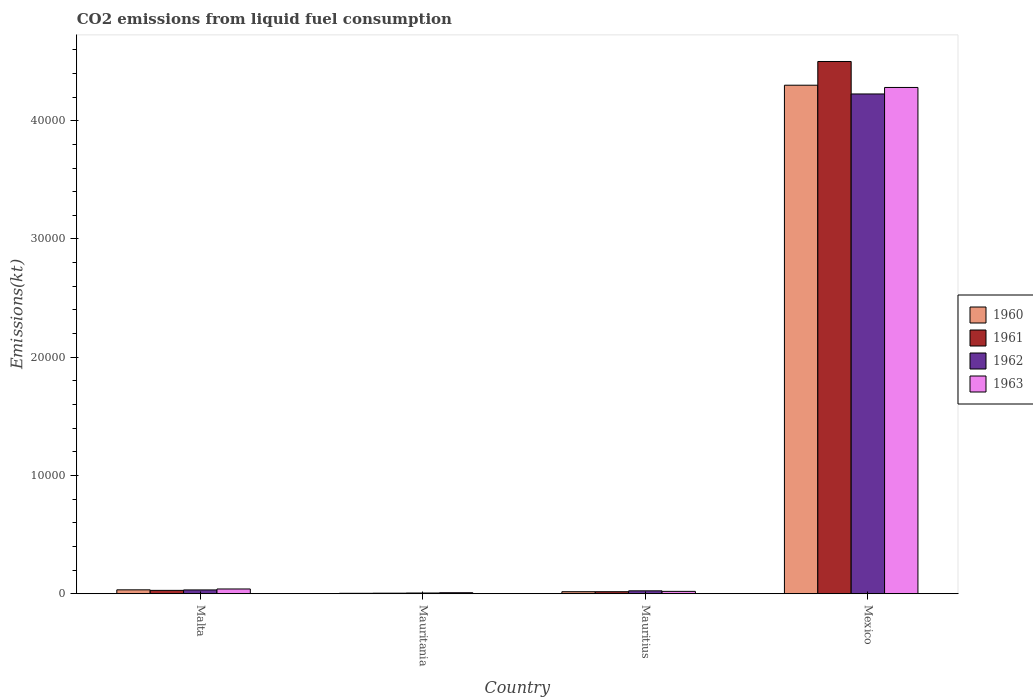How many different coloured bars are there?
Ensure brevity in your answer.  4. How many groups of bars are there?
Your answer should be compact. 4. Are the number of bars per tick equal to the number of legend labels?
Provide a short and direct response. Yes. How many bars are there on the 4th tick from the right?
Offer a very short reply. 4. What is the label of the 2nd group of bars from the left?
Provide a short and direct response. Mauritania. What is the amount of CO2 emitted in 1960 in Malta?
Provide a short and direct response. 330.03. Across all countries, what is the maximum amount of CO2 emitted in 1961?
Ensure brevity in your answer.  4.50e+04. Across all countries, what is the minimum amount of CO2 emitted in 1963?
Ensure brevity in your answer.  88.01. In which country was the amount of CO2 emitted in 1961 minimum?
Your answer should be very brief. Mauritania. What is the total amount of CO2 emitted in 1960 in the graph?
Your answer should be very brief. 4.35e+04. What is the difference between the amount of CO2 emitted in 1962 in Malta and that in Mauritania?
Make the answer very short. 260.36. What is the difference between the amount of CO2 emitted in 1962 in Mexico and the amount of CO2 emitted in 1963 in Mauritius?
Give a very brief answer. 4.21e+04. What is the average amount of CO2 emitted in 1961 per country?
Provide a short and direct response. 1.14e+04. What is the difference between the amount of CO2 emitted of/in 1960 and amount of CO2 emitted of/in 1961 in Mauritania?
Provide a succinct answer. -11. In how many countries, is the amount of CO2 emitted in 1963 greater than 36000 kt?
Ensure brevity in your answer.  1. What is the ratio of the amount of CO2 emitted in 1963 in Malta to that in Mexico?
Your response must be concise. 0.01. Is the amount of CO2 emitted in 1960 in Malta less than that in Mauritania?
Give a very brief answer. No. What is the difference between the highest and the second highest amount of CO2 emitted in 1962?
Your response must be concise. 77.01. What is the difference between the highest and the lowest amount of CO2 emitted in 1962?
Offer a very short reply. 4.22e+04. Is the sum of the amount of CO2 emitted in 1962 in Malta and Mauritius greater than the maximum amount of CO2 emitted in 1960 across all countries?
Make the answer very short. No. Is it the case that in every country, the sum of the amount of CO2 emitted in 1963 and amount of CO2 emitted in 1961 is greater than the sum of amount of CO2 emitted in 1960 and amount of CO2 emitted in 1962?
Provide a short and direct response. No. What does the 2nd bar from the left in Malta represents?
Provide a succinct answer. 1961. How many bars are there?
Make the answer very short. 16. How many countries are there in the graph?
Provide a succinct answer. 4. Does the graph contain any zero values?
Provide a succinct answer. No. Does the graph contain grids?
Give a very brief answer. No. What is the title of the graph?
Your response must be concise. CO2 emissions from liquid fuel consumption. What is the label or title of the X-axis?
Give a very brief answer. Country. What is the label or title of the Y-axis?
Give a very brief answer. Emissions(kt). What is the Emissions(kt) of 1960 in Malta?
Ensure brevity in your answer.  330.03. What is the Emissions(kt) in 1961 in Malta?
Offer a very short reply. 286.03. What is the Emissions(kt) of 1962 in Malta?
Your answer should be very brief. 322.7. What is the Emissions(kt) in 1963 in Malta?
Offer a very short reply. 403.37. What is the Emissions(kt) of 1960 in Mauritania?
Your answer should be very brief. 36.67. What is the Emissions(kt) in 1961 in Mauritania?
Your response must be concise. 47.67. What is the Emissions(kt) in 1962 in Mauritania?
Your answer should be very brief. 62.34. What is the Emissions(kt) in 1963 in Mauritania?
Give a very brief answer. 88.01. What is the Emissions(kt) of 1960 in Mauritius?
Offer a terse response. 172.35. What is the Emissions(kt) in 1961 in Mauritius?
Give a very brief answer. 172.35. What is the Emissions(kt) in 1962 in Mauritius?
Your answer should be compact. 245.69. What is the Emissions(kt) in 1963 in Mauritius?
Make the answer very short. 201.69. What is the Emissions(kt) in 1960 in Mexico?
Provide a short and direct response. 4.30e+04. What is the Emissions(kt) of 1961 in Mexico?
Offer a terse response. 4.50e+04. What is the Emissions(kt) of 1962 in Mexico?
Offer a very short reply. 4.23e+04. What is the Emissions(kt) in 1963 in Mexico?
Provide a succinct answer. 4.28e+04. Across all countries, what is the maximum Emissions(kt) in 1960?
Your answer should be compact. 4.30e+04. Across all countries, what is the maximum Emissions(kt) in 1961?
Your response must be concise. 4.50e+04. Across all countries, what is the maximum Emissions(kt) in 1962?
Provide a succinct answer. 4.23e+04. Across all countries, what is the maximum Emissions(kt) of 1963?
Your answer should be compact. 4.28e+04. Across all countries, what is the minimum Emissions(kt) in 1960?
Make the answer very short. 36.67. Across all countries, what is the minimum Emissions(kt) in 1961?
Keep it short and to the point. 47.67. Across all countries, what is the minimum Emissions(kt) of 1962?
Make the answer very short. 62.34. Across all countries, what is the minimum Emissions(kt) of 1963?
Your answer should be compact. 88.01. What is the total Emissions(kt) in 1960 in the graph?
Provide a succinct answer. 4.35e+04. What is the total Emissions(kt) in 1961 in the graph?
Offer a terse response. 4.55e+04. What is the total Emissions(kt) in 1962 in the graph?
Keep it short and to the point. 4.29e+04. What is the total Emissions(kt) of 1963 in the graph?
Your answer should be very brief. 4.35e+04. What is the difference between the Emissions(kt) of 1960 in Malta and that in Mauritania?
Provide a succinct answer. 293.36. What is the difference between the Emissions(kt) in 1961 in Malta and that in Mauritania?
Offer a terse response. 238.35. What is the difference between the Emissions(kt) of 1962 in Malta and that in Mauritania?
Your response must be concise. 260.36. What is the difference between the Emissions(kt) in 1963 in Malta and that in Mauritania?
Your answer should be compact. 315.36. What is the difference between the Emissions(kt) in 1960 in Malta and that in Mauritius?
Provide a short and direct response. 157.68. What is the difference between the Emissions(kt) in 1961 in Malta and that in Mauritius?
Your answer should be compact. 113.68. What is the difference between the Emissions(kt) of 1962 in Malta and that in Mauritius?
Provide a short and direct response. 77.01. What is the difference between the Emissions(kt) in 1963 in Malta and that in Mauritius?
Give a very brief answer. 201.69. What is the difference between the Emissions(kt) in 1960 in Malta and that in Mexico?
Make the answer very short. -4.27e+04. What is the difference between the Emissions(kt) in 1961 in Malta and that in Mexico?
Give a very brief answer. -4.47e+04. What is the difference between the Emissions(kt) of 1962 in Malta and that in Mexico?
Offer a terse response. -4.19e+04. What is the difference between the Emissions(kt) in 1963 in Malta and that in Mexico?
Offer a very short reply. -4.24e+04. What is the difference between the Emissions(kt) in 1960 in Mauritania and that in Mauritius?
Your answer should be very brief. -135.68. What is the difference between the Emissions(kt) in 1961 in Mauritania and that in Mauritius?
Offer a terse response. -124.68. What is the difference between the Emissions(kt) of 1962 in Mauritania and that in Mauritius?
Offer a very short reply. -183.35. What is the difference between the Emissions(kt) in 1963 in Mauritania and that in Mauritius?
Make the answer very short. -113.68. What is the difference between the Emissions(kt) in 1960 in Mauritania and that in Mexico?
Offer a terse response. -4.30e+04. What is the difference between the Emissions(kt) in 1961 in Mauritania and that in Mexico?
Your answer should be compact. -4.50e+04. What is the difference between the Emissions(kt) of 1962 in Mauritania and that in Mexico?
Offer a terse response. -4.22e+04. What is the difference between the Emissions(kt) of 1963 in Mauritania and that in Mexico?
Offer a very short reply. -4.27e+04. What is the difference between the Emissions(kt) of 1960 in Mauritius and that in Mexico?
Offer a very short reply. -4.28e+04. What is the difference between the Emissions(kt) of 1961 in Mauritius and that in Mexico?
Give a very brief answer. -4.48e+04. What is the difference between the Emissions(kt) of 1962 in Mauritius and that in Mexico?
Give a very brief answer. -4.20e+04. What is the difference between the Emissions(kt) of 1963 in Mauritius and that in Mexico?
Your answer should be very brief. -4.26e+04. What is the difference between the Emissions(kt) in 1960 in Malta and the Emissions(kt) in 1961 in Mauritania?
Your answer should be very brief. 282.36. What is the difference between the Emissions(kt) in 1960 in Malta and the Emissions(kt) in 1962 in Mauritania?
Give a very brief answer. 267.69. What is the difference between the Emissions(kt) in 1960 in Malta and the Emissions(kt) in 1963 in Mauritania?
Keep it short and to the point. 242.02. What is the difference between the Emissions(kt) in 1961 in Malta and the Emissions(kt) in 1962 in Mauritania?
Make the answer very short. 223.69. What is the difference between the Emissions(kt) in 1961 in Malta and the Emissions(kt) in 1963 in Mauritania?
Offer a very short reply. 198.02. What is the difference between the Emissions(kt) of 1962 in Malta and the Emissions(kt) of 1963 in Mauritania?
Your answer should be very brief. 234.69. What is the difference between the Emissions(kt) in 1960 in Malta and the Emissions(kt) in 1961 in Mauritius?
Give a very brief answer. 157.68. What is the difference between the Emissions(kt) in 1960 in Malta and the Emissions(kt) in 1962 in Mauritius?
Your answer should be very brief. 84.34. What is the difference between the Emissions(kt) in 1960 in Malta and the Emissions(kt) in 1963 in Mauritius?
Provide a succinct answer. 128.34. What is the difference between the Emissions(kt) of 1961 in Malta and the Emissions(kt) of 1962 in Mauritius?
Provide a succinct answer. 40.34. What is the difference between the Emissions(kt) in 1961 in Malta and the Emissions(kt) in 1963 in Mauritius?
Your answer should be compact. 84.34. What is the difference between the Emissions(kt) in 1962 in Malta and the Emissions(kt) in 1963 in Mauritius?
Ensure brevity in your answer.  121.01. What is the difference between the Emissions(kt) in 1960 in Malta and the Emissions(kt) in 1961 in Mexico?
Provide a short and direct response. -4.47e+04. What is the difference between the Emissions(kt) in 1960 in Malta and the Emissions(kt) in 1962 in Mexico?
Make the answer very short. -4.19e+04. What is the difference between the Emissions(kt) of 1960 in Malta and the Emissions(kt) of 1963 in Mexico?
Ensure brevity in your answer.  -4.25e+04. What is the difference between the Emissions(kt) of 1961 in Malta and the Emissions(kt) of 1962 in Mexico?
Ensure brevity in your answer.  -4.20e+04. What is the difference between the Emissions(kt) in 1961 in Malta and the Emissions(kt) in 1963 in Mexico?
Offer a terse response. -4.25e+04. What is the difference between the Emissions(kt) of 1962 in Malta and the Emissions(kt) of 1963 in Mexico?
Provide a succinct answer. -4.25e+04. What is the difference between the Emissions(kt) of 1960 in Mauritania and the Emissions(kt) of 1961 in Mauritius?
Provide a succinct answer. -135.68. What is the difference between the Emissions(kt) in 1960 in Mauritania and the Emissions(kt) in 1962 in Mauritius?
Keep it short and to the point. -209.02. What is the difference between the Emissions(kt) of 1960 in Mauritania and the Emissions(kt) of 1963 in Mauritius?
Your response must be concise. -165.01. What is the difference between the Emissions(kt) of 1961 in Mauritania and the Emissions(kt) of 1962 in Mauritius?
Give a very brief answer. -198.02. What is the difference between the Emissions(kt) in 1961 in Mauritania and the Emissions(kt) in 1963 in Mauritius?
Your response must be concise. -154.01. What is the difference between the Emissions(kt) of 1962 in Mauritania and the Emissions(kt) of 1963 in Mauritius?
Give a very brief answer. -139.35. What is the difference between the Emissions(kt) in 1960 in Mauritania and the Emissions(kt) in 1961 in Mexico?
Your response must be concise. -4.50e+04. What is the difference between the Emissions(kt) in 1960 in Mauritania and the Emissions(kt) in 1962 in Mexico?
Your answer should be very brief. -4.22e+04. What is the difference between the Emissions(kt) in 1960 in Mauritania and the Emissions(kt) in 1963 in Mexico?
Offer a terse response. -4.28e+04. What is the difference between the Emissions(kt) in 1961 in Mauritania and the Emissions(kt) in 1962 in Mexico?
Provide a succinct answer. -4.22e+04. What is the difference between the Emissions(kt) in 1961 in Mauritania and the Emissions(kt) in 1963 in Mexico?
Make the answer very short. -4.28e+04. What is the difference between the Emissions(kt) in 1962 in Mauritania and the Emissions(kt) in 1963 in Mexico?
Give a very brief answer. -4.27e+04. What is the difference between the Emissions(kt) of 1960 in Mauritius and the Emissions(kt) of 1961 in Mexico?
Your answer should be compact. -4.48e+04. What is the difference between the Emissions(kt) in 1960 in Mauritius and the Emissions(kt) in 1962 in Mexico?
Your answer should be very brief. -4.21e+04. What is the difference between the Emissions(kt) of 1960 in Mauritius and the Emissions(kt) of 1963 in Mexico?
Ensure brevity in your answer.  -4.26e+04. What is the difference between the Emissions(kt) in 1961 in Mauritius and the Emissions(kt) in 1962 in Mexico?
Make the answer very short. -4.21e+04. What is the difference between the Emissions(kt) in 1961 in Mauritius and the Emissions(kt) in 1963 in Mexico?
Give a very brief answer. -4.26e+04. What is the difference between the Emissions(kt) in 1962 in Mauritius and the Emissions(kt) in 1963 in Mexico?
Make the answer very short. -4.26e+04. What is the average Emissions(kt) of 1960 per country?
Offer a terse response. 1.09e+04. What is the average Emissions(kt) of 1961 per country?
Give a very brief answer. 1.14e+04. What is the average Emissions(kt) of 1962 per country?
Provide a succinct answer. 1.07e+04. What is the average Emissions(kt) in 1963 per country?
Provide a succinct answer. 1.09e+04. What is the difference between the Emissions(kt) in 1960 and Emissions(kt) in 1961 in Malta?
Offer a terse response. 44. What is the difference between the Emissions(kt) of 1960 and Emissions(kt) of 1962 in Malta?
Provide a short and direct response. 7.33. What is the difference between the Emissions(kt) of 1960 and Emissions(kt) of 1963 in Malta?
Offer a very short reply. -73.34. What is the difference between the Emissions(kt) in 1961 and Emissions(kt) in 1962 in Malta?
Give a very brief answer. -36.67. What is the difference between the Emissions(kt) of 1961 and Emissions(kt) of 1963 in Malta?
Provide a succinct answer. -117.34. What is the difference between the Emissions(kt) of 1962 and Emissions(kt) of 1963 in Malta?
Make the answer very short. -80.67. What is the difference between the Emissions(kt) in 1960 and Emissions(kt) in 1961 in Mauritania?
Your answer should be compact. -11. What is the difference between the Emissions(kt) of 1960 and Emissions(kt) of 1962 in Mauritania?
Give a very brief answer. -25.67. What is the difference between the Emissions(kt) in 1960 and Emissions(kt) in 1963 in Mauritania?
Make the answer very short. -51.34. What is the difference between the Emissions(kt) in 1961 and Emissions(kt) in 1962 in Mauritania?
Offer a terse response. -14.67. What is the difference between the Emissions(kt) in 1961 and Emissions(kt) in 1963 in Mauritania?
Ensure brevity in your answer.  -40.34. What is the difference between the Emissions(kt) in 1962 and Emissions(kt) in 1963 in Mauritania?
Provide a short and direct response. -25.67. What is the difference between the Emissions(kt) of 1960 and Emissions(kt) of 1962 in Mauritius?
Offer a terse response. -73.34. What is the difference between the Emissions(kt) of 1960 and Emissions(kt) of 1963 in Mauritius?
Your answer should be compact. -29.34. What is the difference between the Emissions(kt) in 1961 and Emissions(kt) in 1962 in Mauritius?
Provide a short and direct response. -73.34. What is the difference between the Emissions(kt) in 1961 and Emissions(kt) in 1963 in Mauritius?
Provide a short and direct response. -29.34. What is the difference between the Emissions(kt) of 1962 and Emissions(kt) of 1963 in Mauritius?
Ensure brevity in your answer.  44. What is the difference between the Emissions(kt) of 1960 and Emissions(kt) of 1961 in Mexico?
Give a very brief answer. -2005.85. What is the difference between the Emissions(kt) in 1960 and Emissions(kt) in 1962 in Mexico?
Your answer should be compact. 740.73. What is the difference between the Emissions(kt) in 1960 and Emissions(kt) in 1963 in Mexico?
Provide a short and direct response. 190.68. What is the difference between the Emissions(kt) in 1961 and Emissions(kt) in 1962 in Mexico?
Provide a succinct answer. 2746.58. What is the difference between the Emissions(kt) of 1961 and Emissions(kt) of 1963 in Mexico?
Make the answer very short. 2196.53. What is the difference between the Emissions(kt) in 1962 and Emissions(kt) in 1963 in Mexico?
Provide a succinct answer. -550.05. What is the ratio of the Emissions(kt) in 1962 in Malta to that in Mauritania?
Provide a short and direct response. 5.18. What is the ratio of the Emissions(kt) of 1963 in Malta to that in Mauritania?
Ensure brevity in your answer.  4.58. What is the ratio of the Emissions(kt) in 1960 in Malta to that in Mauritius?
Keep it short and to the point. 1.91. What is the ratio of the Emissions(kt) of 1961 in Malta to that in Mauritius?
Your answer should be compact. 1.66. What is the ratio of the Emissions(kt) of 1962 in Malta to that in Mauritius?
Your response must be concise. 1.31. What is the ratio of the Emissions(kt) in 1960 in Malta to that in Mexico?
Offer a very short reply. 0.01. What is the ratio of the Emissions(kt) of 1961 in Malta to that in Mexico?
Provide a short and direct response. 0.01. What is the ratio of the Emissions(kt) in 1962 in Malta to that in Mexico?
Offer a terse response. 0.01. What is the ratio of the Emissions(kt) in 1963 in Malta to that in Mexico?
Offer a terse response. 0.01. What is the ratio of the Emissions(kt) in 1960 in Mauritania to that in Mauritius?
Keep it short and to the point. 0.21. What is the ratio of the Emissions(kt) in 1961 in Mauritania to that in Mauritius?
Your response must be concise. 0.28. What is the ratio of the Emissions(kt) in 1962 in Mauritania to that in Mauritius?
Your response must be concise. 0.25. What is the ratio of the Emissions(kt) of 1963 in Mauritania to that in Mauritius?
Your answer should be compact. 0.44. What is the ratio of the Emissions(kt) in 1960 in Mauritania to that in Mexico?
Make the answer very short. 0. What is the ratio of the Emissions(kt) of 1961 in Mauritania to that in Mexico?
Offer a terse response. 0. What is the ratio of the Emissions(kt) in 1962 in Mauritania to that in Mexico?
Your answer should be very brief. 0. What is the ratio of the Emissions(kt) of 1963 in Mauritania to that in Mexico?
Provide a short and direct response. 0. What is the ratio of the Emissions(kt) in 1960 in Mauritius to that in Mexico?
Ensure brevity in your answer.  0. What is the ratio of the Emissions(kt) in 1961 in Mauritius to that in Mexico?
Keep it short and to the point. 0. What is the ratio of the Emissions(kt) of 1962 in Mauritius to that in Mexico?
Keep it short and to the point. 0.01. What is the ratio of the Emissions(kt) of 1963 in Mauritius to that in Mexico?
Provide a short and direct response. 0. What is the difference between the highest and the second highest Emissions(kt) of 1960?
Make the answer very short. 4.27e+04. What is the difference between the highest and the second highest Emissions(kt) in 1961?
Provide a succinct answer. 4.47e+04. What is the difference between the highest and the second highest Emissions(kt) of 1962?
Ensure brevity in your answer.  4.19e+04. What is the difference between the highest and the second highest Emissions(kt) of 1963?
Provide a short and direct response. 4.24e+04. What is the difference between the highest and the lowest Emissions(kt) in 1960?
Your answer should be compact. 4.30e+04. What is the difference between the highest and the lowest Emissions(kt) in 1961?
Your answer should be very brief. 4.50e+04. What is the difference between the highest and the lowest Emissions(kt) in 1962?
Give a very brief answer. 4.22e+04. What is the difference between the highest and the lowest Emissions(kt) in 1963?
Make the answer very short. 4.27e+04. 